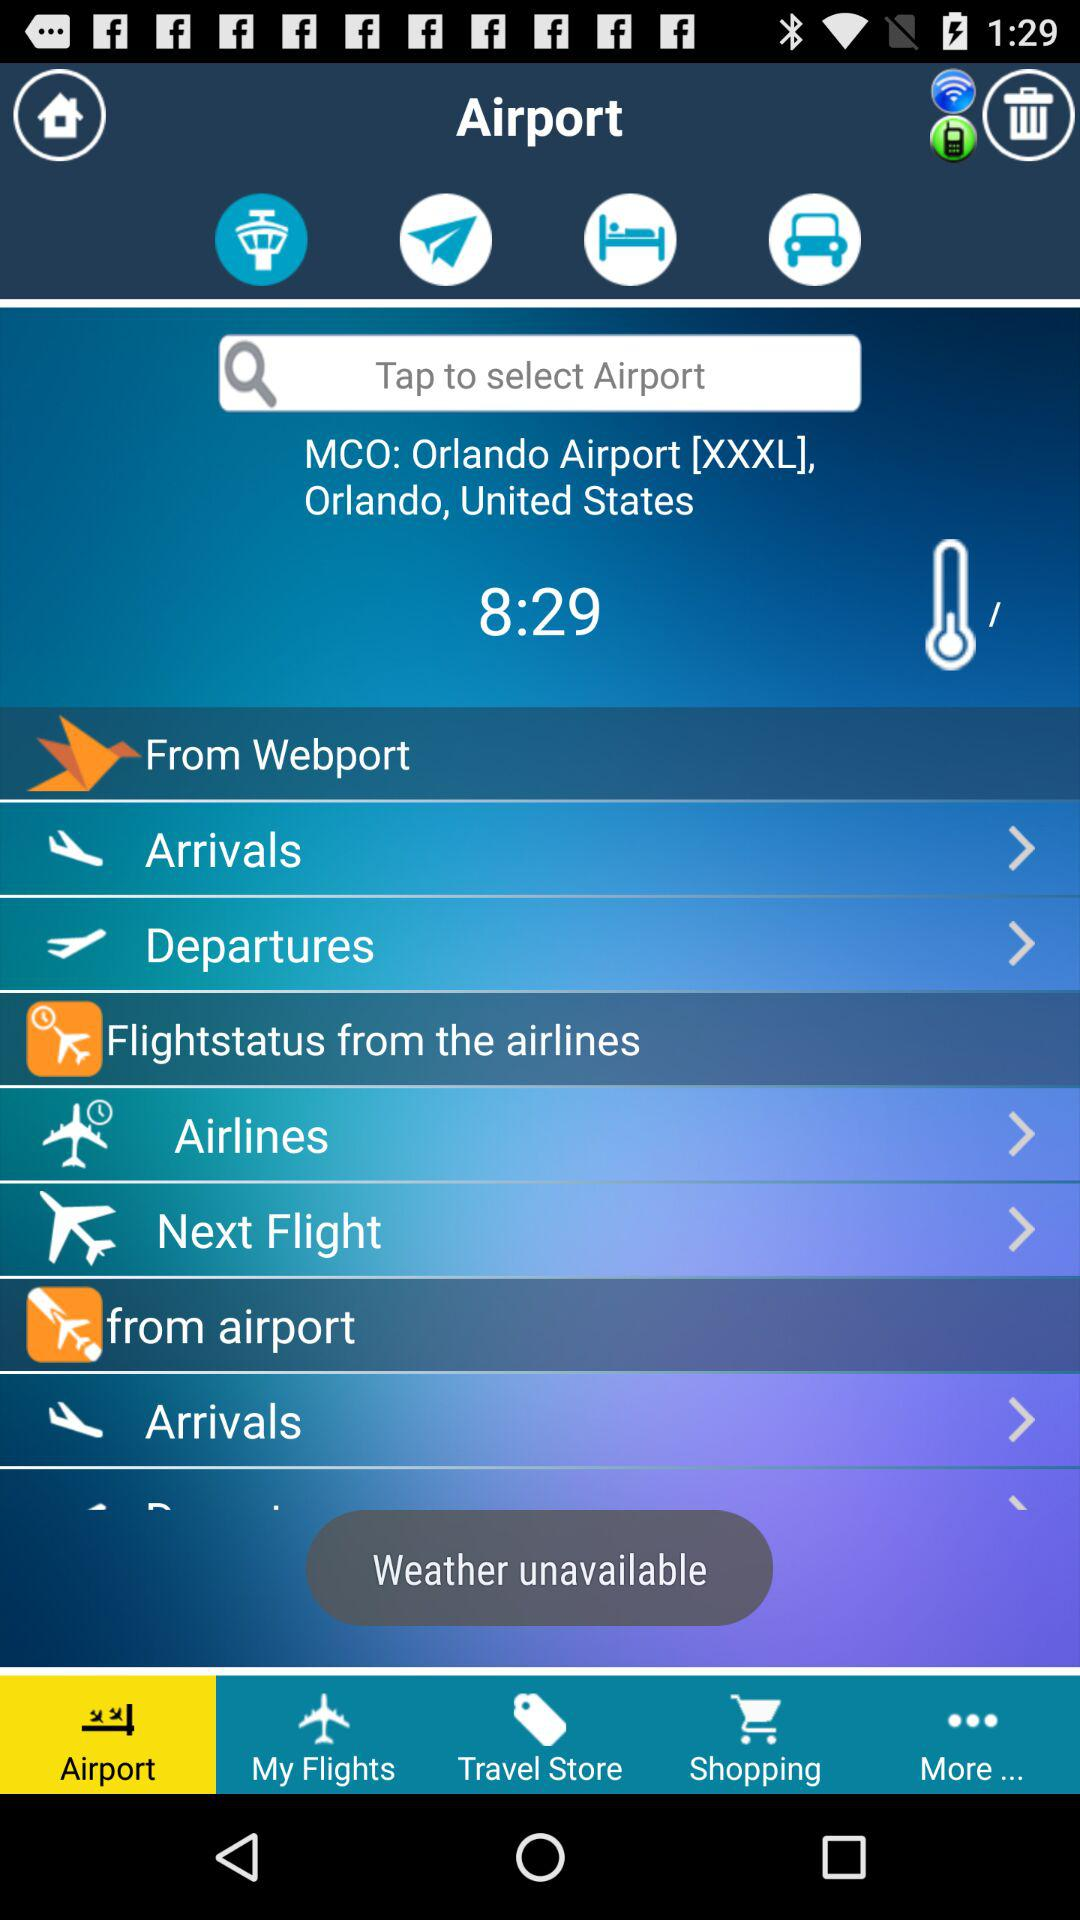Which tab is selected? The selected tab is "Airport". 